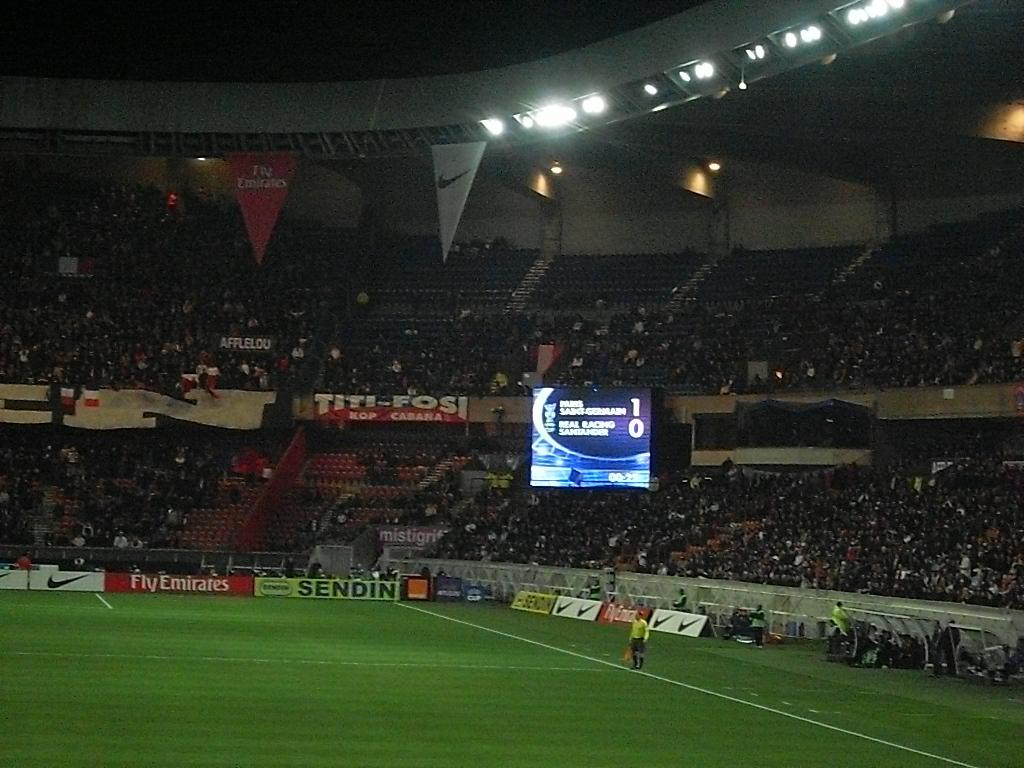<image>
Give a short and clear explanation of the subsequent image. Emirate Airlines frequently acts as a sponsor in big soccer competition. 